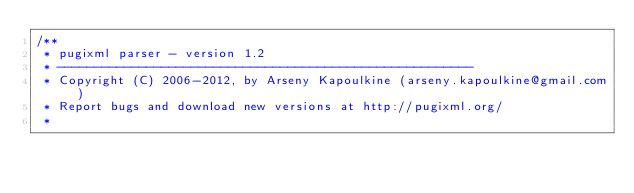<code> <loc_0><loc_0><loc_500><loc_500><_C++_>/**
 * pugixml parser - version 1.2
 * --------------------------------------------------------
 * Copyright (C) 2006-2012, by Arseny Kapoulkine (arseny.kapoulkine@gmail.com)
 * Report bugs and download new versions at http://pugixml.org/
 *</code> 